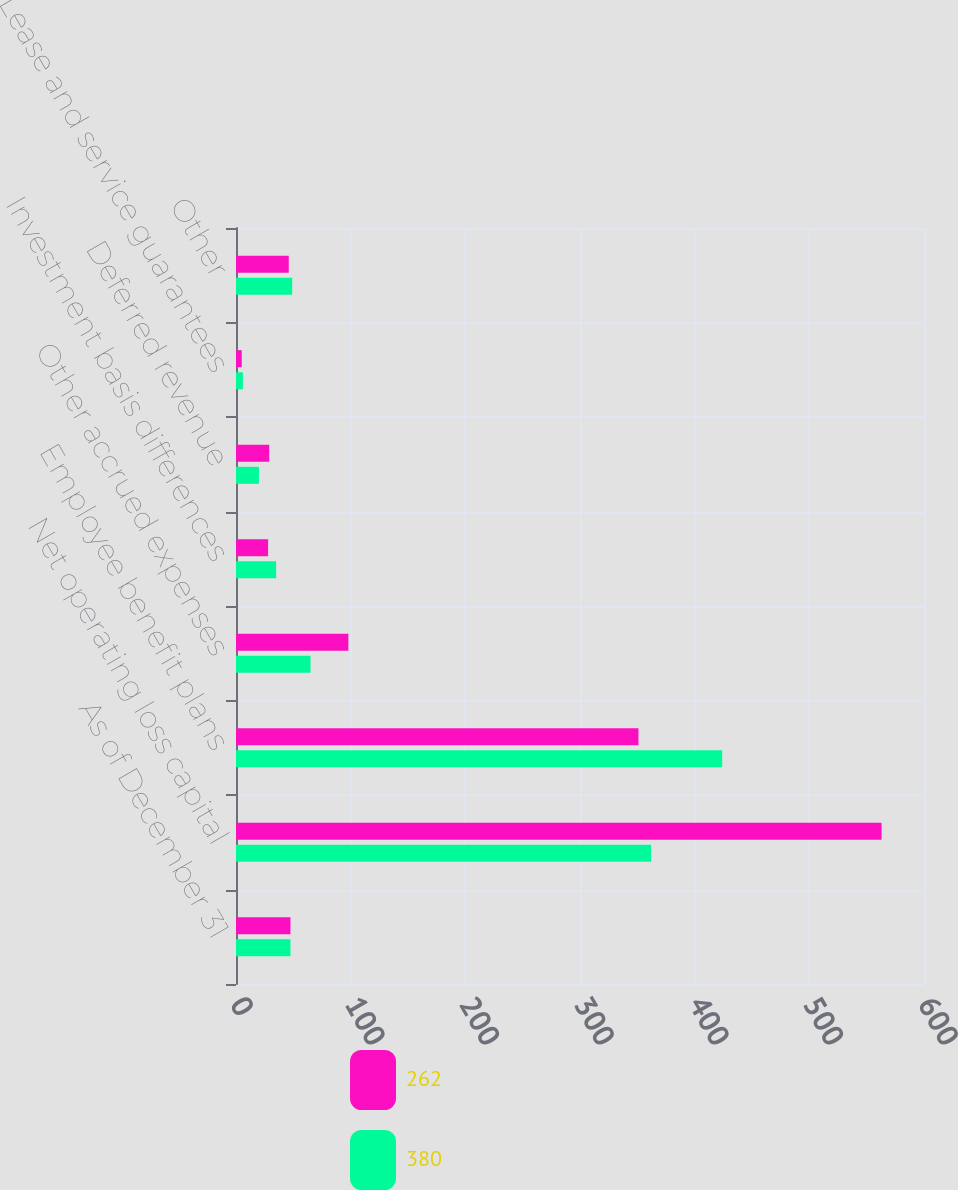Convert chart to OTSL. <chart><loc_0><loc_0><loc_500><loc_500><stacked_bar_chart><ecel><fcel>As of December 31<fcel>Net operating loss capital<fcel>Employee benefit plans<fcel>Other accrued expenses<fcel>Investment basis differences<fcel>Deferred revenue<fcel>Lease and service guarantees<fcel>Other<nl><fcel>262<fcel>47.5<fcel>563<fcel>351<fcel>98<fcel>28<fcel>29<fcel>5<fcel>46<nl><fcel>380<fcel>47.5<fcel>362<fcel>424<fcel>65<fcel>35<fcel>20<fcel>6<fcel>49<nl></chart> 